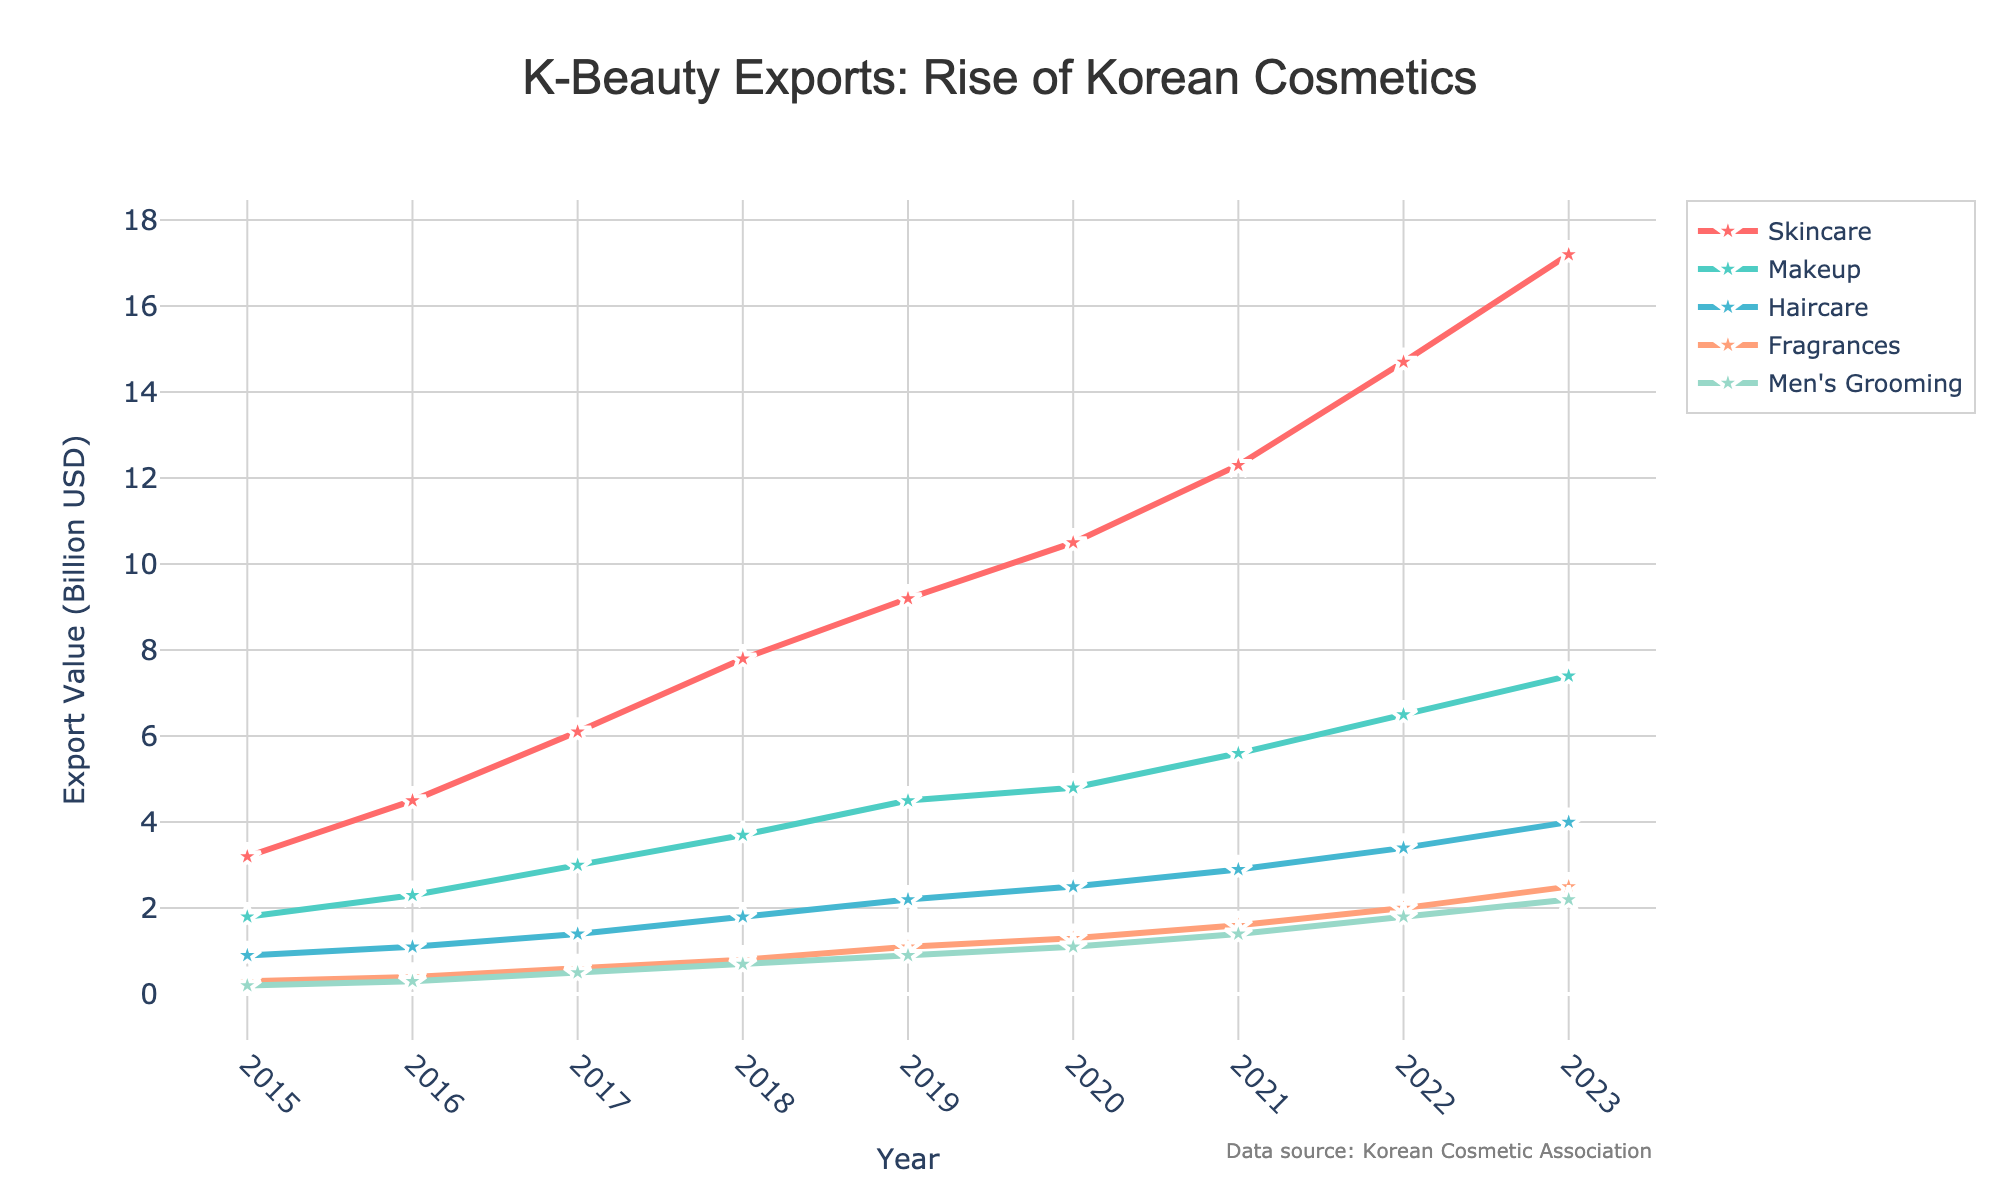What was the total export value for Skincare and Makeup products in the Year 2020? To find the total export value for Skincare and Makeup in 2020, add the values: 10.5 (Skincare) + 4.8 (Makeup) = 15.3 billion USD
Answer: 15.3 billion USD Which product category had the highest export value in 2023? By looking at the year 2023 data points, Skincare had the highest value at 17.2 billion USD compared to other product categories.
Answer: Skincare How did the export value of Haircare change from 2019 to 2021? The export value of Haircare was 2.2 billion USD in 2019 and increased to 2.9 billion USD in 2021. Therefore the change is 2.9 - 2.2 = 0.7 billion USD.
Answer: 0.7 billion USD Which product category had the least growth from 2015 to 2023? Calculate the difference for each category: 
- Skincare: 17.2 - 3.2 = 14 billion USD
- Makeup: 7.4 - 1.8 = 5.6 billion USD
- Haircare: 4.0 - 0.9 = 3.1 billion USD
- Fragrances: 2.5 - 0.3 = 2.2 billion USD
- Men's Grooming: 2.2 - 0.2 = 2 billion USD
Men's Grooming had the least growth.
Answer: Men's Grooming Compare the export value of Fragrances in 2020 and 2022. What do you observe? In 2020, the Fragrances export value was 1.3 billion USD and in 2022 it increased to 2.0 billion USD. The value increased by 2.0 - 1.3 = 0.7 billion USD over two years.
Answer: Increase by 0.7 billion USD What was the average export value of Men's Grooming products from 2015 to 2023? Sum up the Men's Grooming values and divide by the number of years: (0.2 + 0.3 + 0.5 + 0.7 + 0.9 + 1.1 + 1.4 + 1.8 + 2.2) / 9 ≈ 1.1 billion USD
Answer: 1.1 billion USD Which two product categories had the closest export values in 2016? In 2016, compare the values:
- Skincare: 4.5
- Makeup: 2.3
- Haircare: 1.1
- Fragrances: 0.4
- Men's Grooming: 0.3
Fragrances and Men's Grooming were closest, differing by only 0.1 billion USD.
Answer: Fragrances and Men's Grooming Identify the year in which Makeup saw the highest increase compared to the previous year. To identify the highest increase, compare the year-to-year difference for Makeup:
- 2016: 2.3 - 1.8 = 0.5
- 2017: 3.0 - 2.3 = 0.7
- 2018: 3.7 - 3.0 = 0.7
- 2019: 4.5 - 3.7 = 0.8
- 2020: 4.8 - 4.5 = 0.3
- 2021: 5.6 - 4.8 = 0.8
- 2022: 6.5 - 5.6 = 0.9
- 2023: 7.4 - 6.5 = 0.9
2022 and 2023 tied for the highest increase at 0.9 billion USD.
Answer: 2022 and 2023 